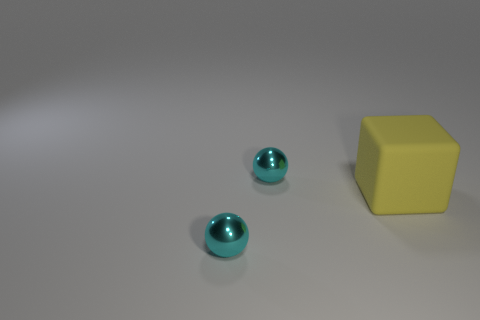How many cyan balls have the same material as the large object?
Offer a terse response. 0. Do the tiny metallic sphere in front of the yellow block and the rubber cube have the same color?
Offer a terse response. No. There is a small object that is in front of the big yellow matte block; what material is it?
Your response must be concise. Metal. Are there the same number of big yellow objects on the left side of the matte object and big blue shiny objects?
Make the answer very short. Yes. How many other blocks have the same color as the large matte block?
Your answer should be compact. 0. Are there any tiny cyan things?
Your answer should be compact. Yes. There is a cyan object in front of the big yellow thing; what is its size?
Give a very brief answer. Small. Is the number of cyan things that are in front of the large yellow cube greater than the number of yellow blocks?
Provide a short and direct response. No. What shape is the big object?
Provide a short and direct response. Cube. Is the color of the shiny thing behind the cube the same as the small ball that is in front of the yellow cube?
Offer a very short reply. Yes. 